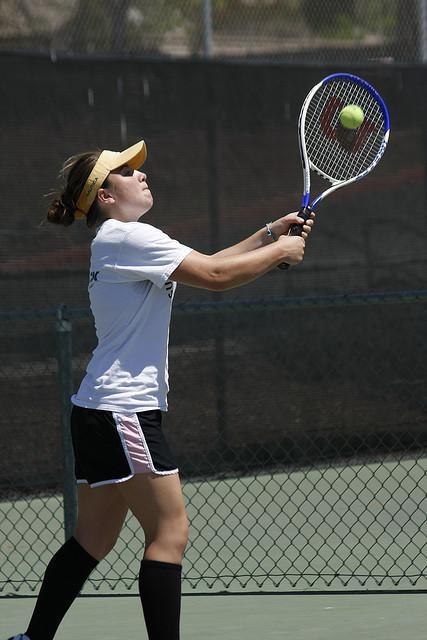What is the most common tennis racquet string material? Please explain your reasoning. animal guts. The girl looks like a beginner and beginner tennis rackets use animal guts for strings. 